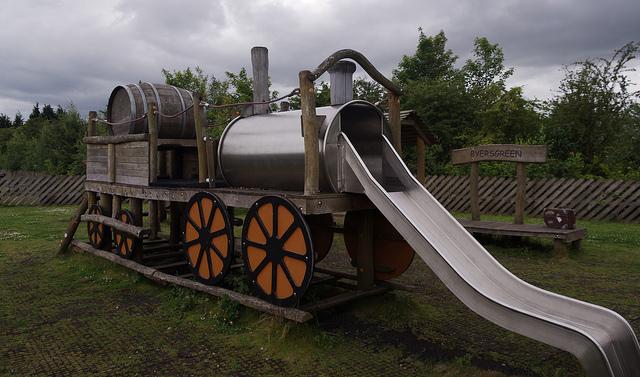Is that slide metal?
Give a very brief answer. Yes. What does this train run on?
Be succinct. Nothing. Does this appear to be a sunny day?
Answer briefly. No. Is the park empty?
Concise answer only. Yes. Why aren't there any kids playing?
Give a very brief answer. Weather. How many tennis balls are present in this picture?
Write a very short answer. 0. Is it sunny?
Write a very short answer. No. 